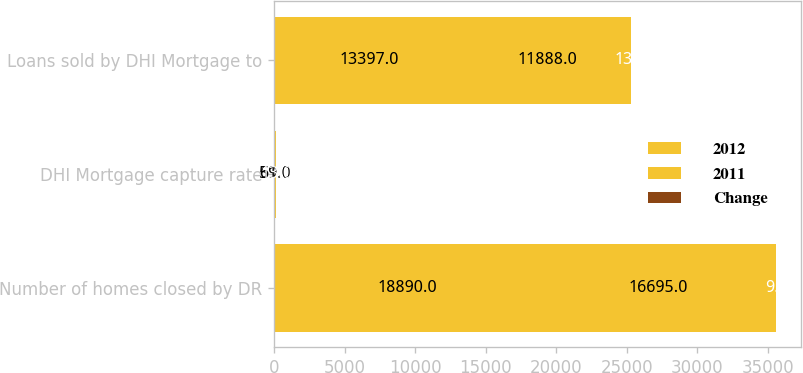<chart> <loc_0><loc_0><loc_500><loc_500><stacked_bar_chart><ecel><fcel>Number of homes closed by DR<fcel>DHI Mortgage capture rate<fcel>Loans sold by DHI Mortgage to<nl><fcel>2012<fcel>18890<fcel>59<fcel>13397<nl><fcel>2011<fcel>16695<fcel>61<fcel>11888<nl><fcel>Change<fcel>9<fcel>13<fcel>13<nl></chart> 